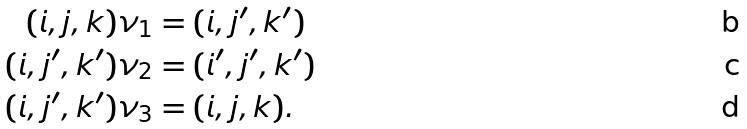Convert formula to latex. <formula><loc_0><loc_0><loc_500><loc_500>( i , j , k ) \nu _ { 1 } & = ( i , j ^ { \prime } , k ^ { \prime } ) \\ ( i , j ^ { \prime } , k ^ { \prime } ) \nu _ { 2 } & = ( i ^ { \prime } , j ^ { \prime } , k ^ { \prime } ) \\ ( i , j ^ { \prime } , k ^ { \prime } ) \nu _ { 3 } & = ( i , j , k ) .</formula> 